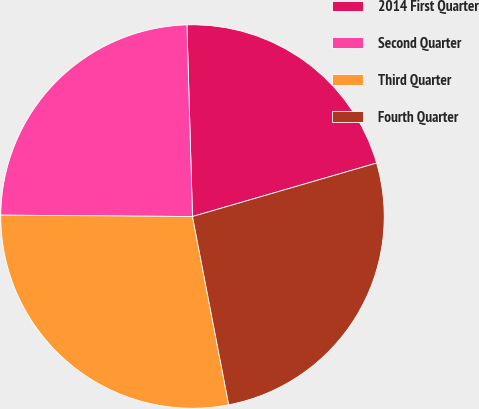Convert chart to OTSL. <chart><loc_0><loc_0><loc_500><loc_500><pie_chart><fcel>2014 First Quarter<fcel>Second Quarter<fcel>Third Quarter<fcel>Fourth Quarter<nl><fcel>20.96%<fcel>24.42%<fcel>28.14%<fcel>26.47%<nl></chart> 